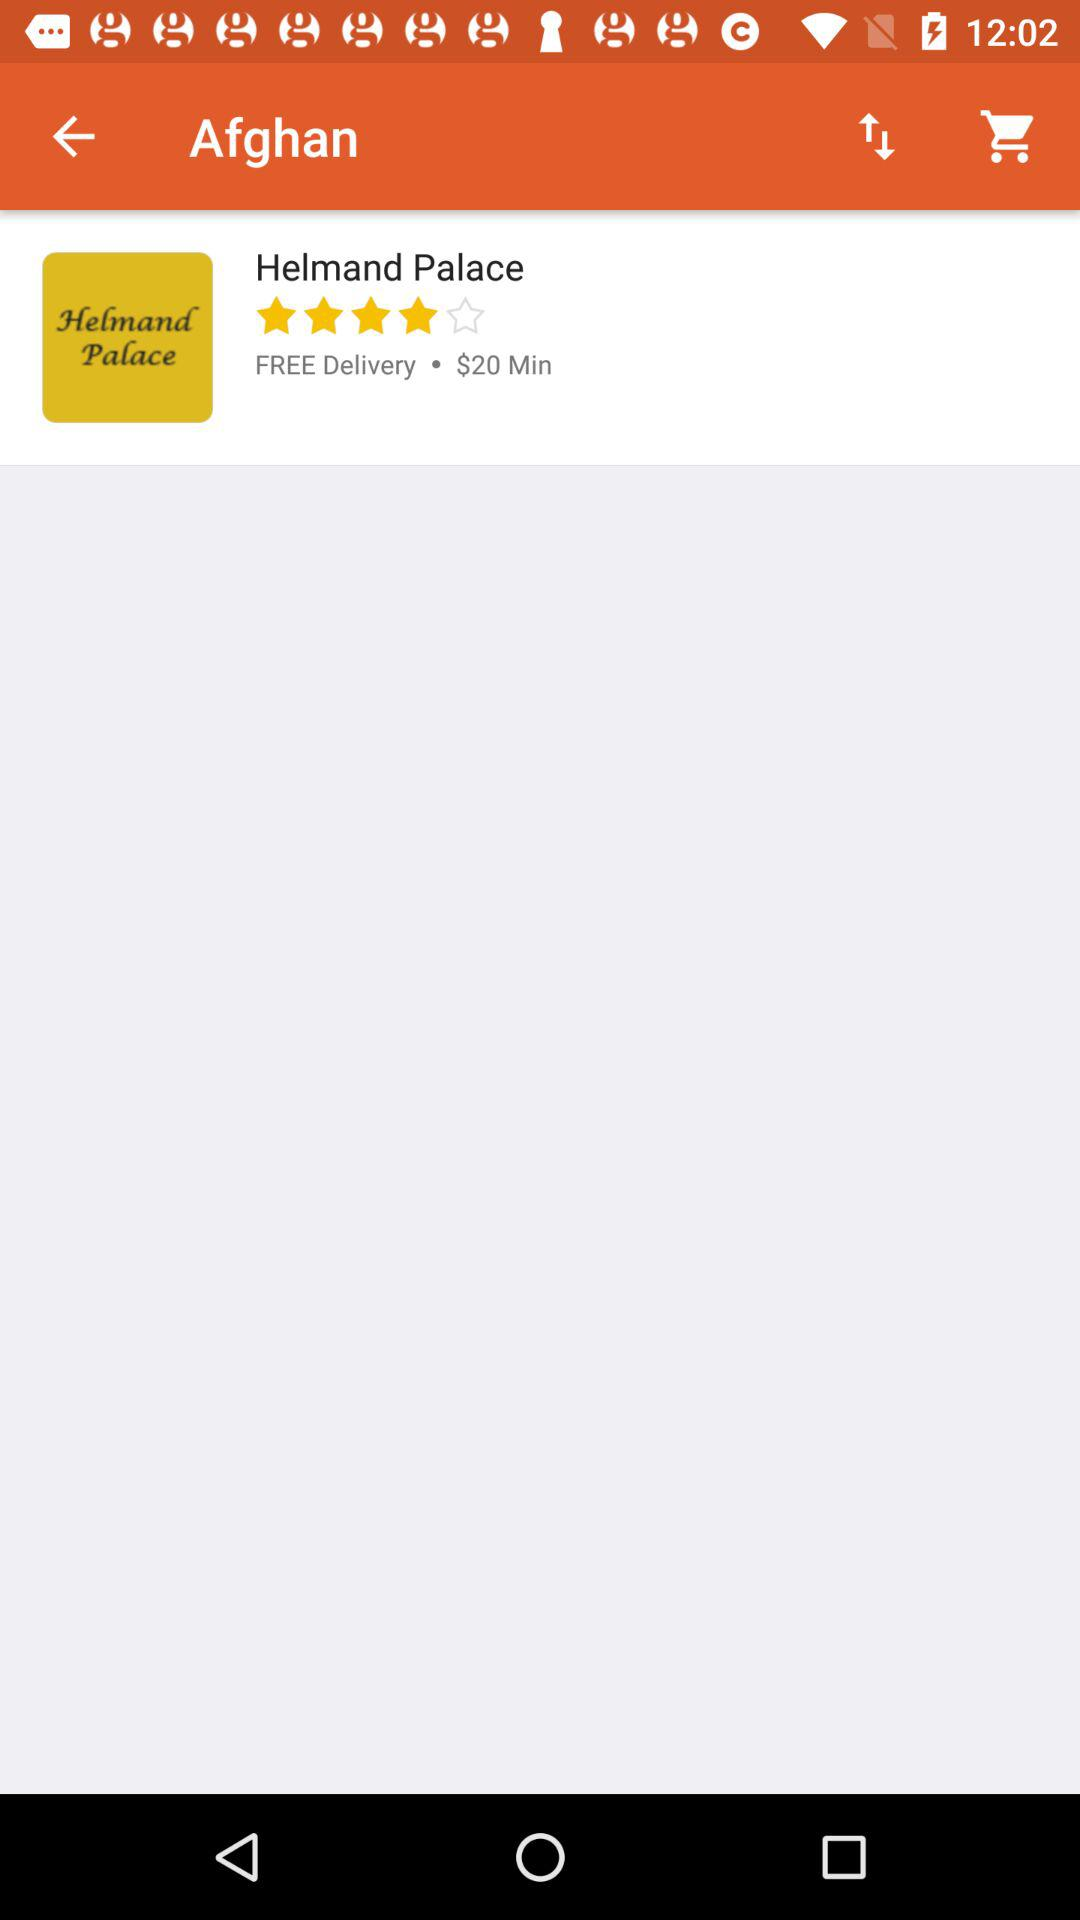What is the rating? The rating is 4 stars. 